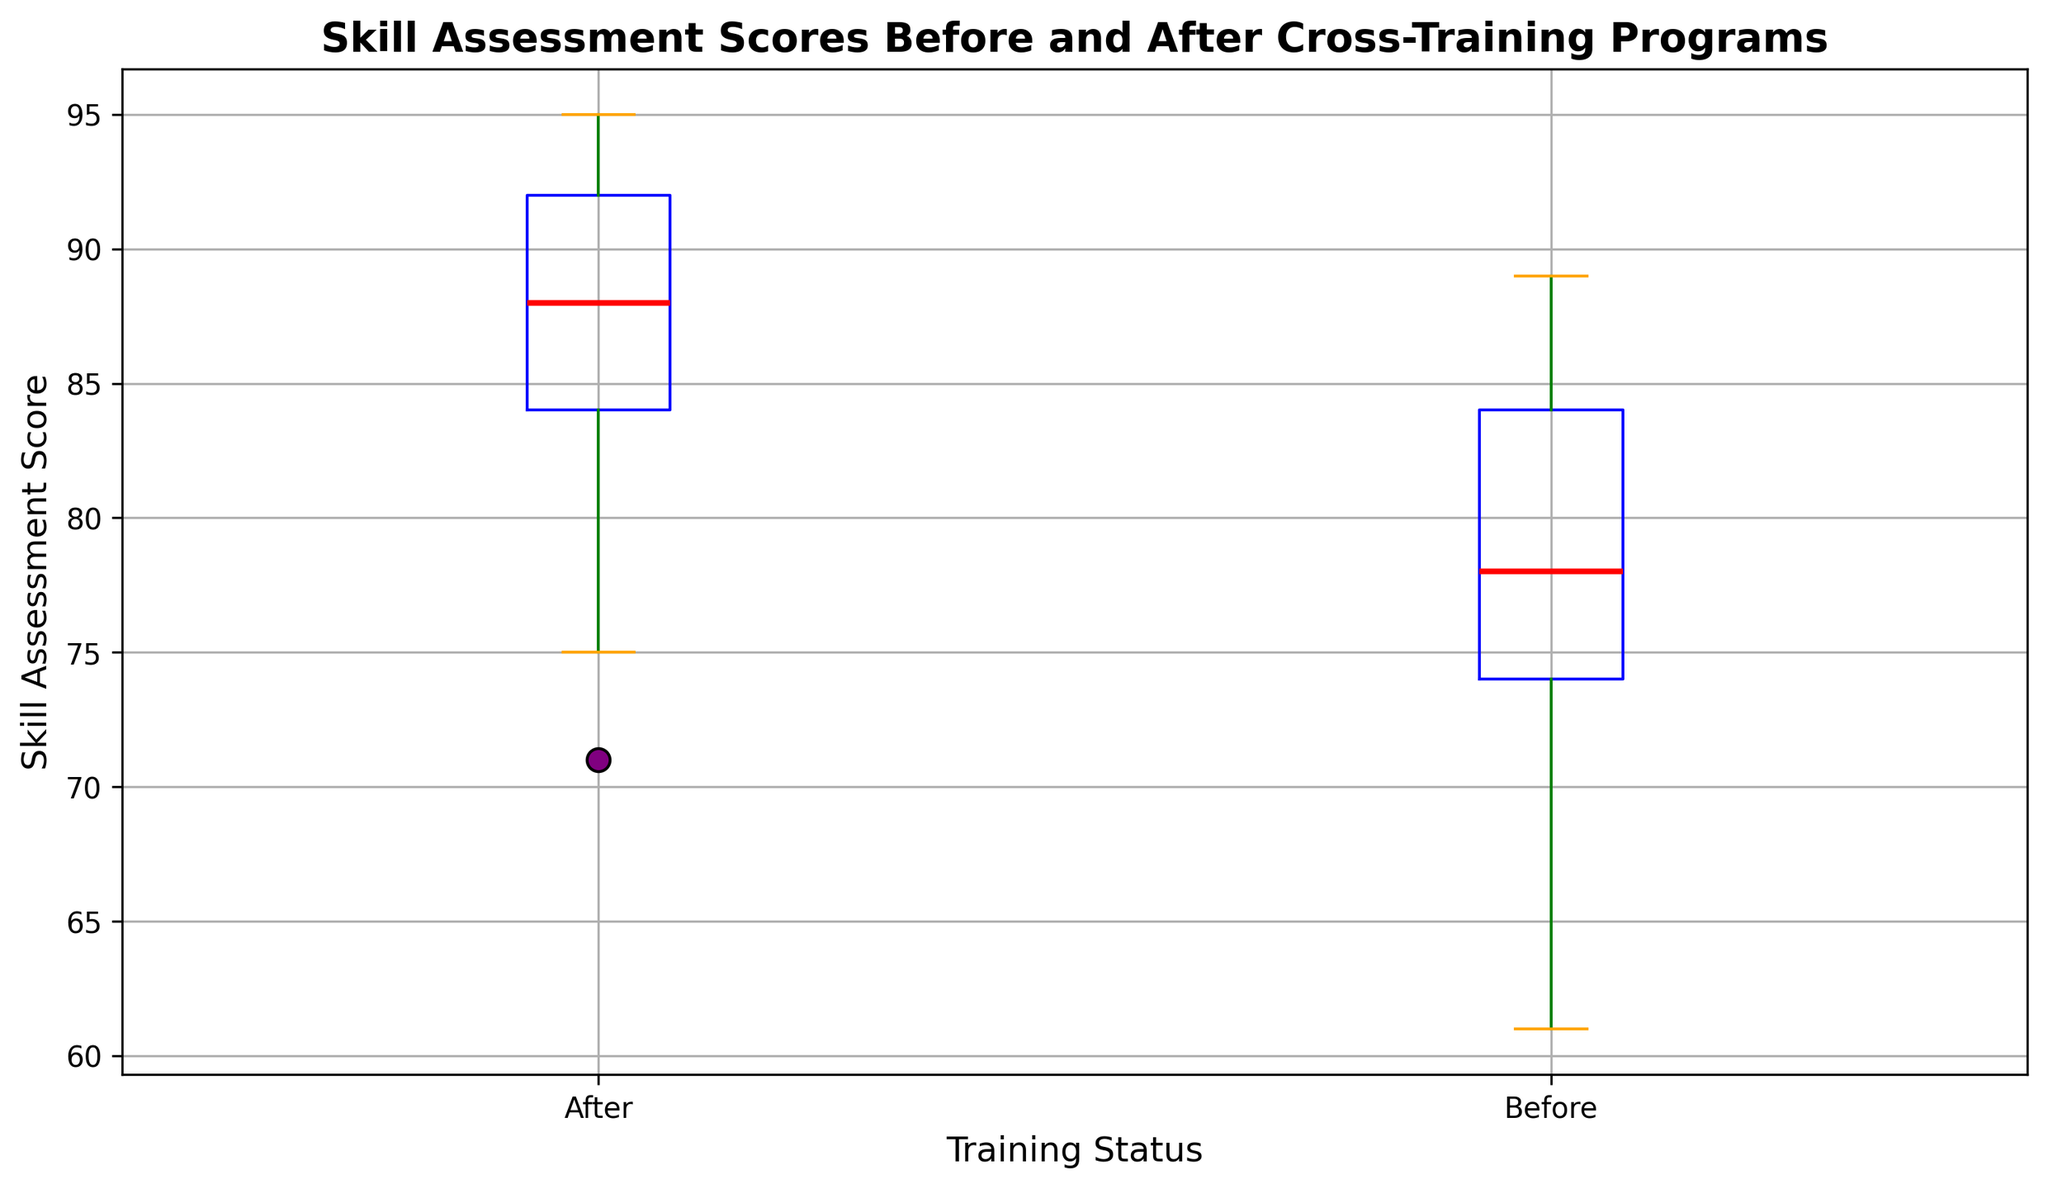What's the difference in the median skill assessment scores before and after cross-training programs? To find the difference, identify the median values for the two groups. The median value is the red line inside each box. Subtract the median "Before" score from the median "After" score.
Answer: 10 Which training status has a higher variability in skill assessment scores? Variability is represented by the length of the box and whiskers. The "Before" box appears taller and its whiskers are longer, indicating higher variability compared to the "After" box.
Answer: Before What is the interquartile range (IQR) of the skill assessment scores after cross-training programs? The IQR is the range covered by the box, which represents the middle 50% of the data. Find the values at the top (Q3) and bottom (Q1) of the box for the "After" group and subtract Q1 from Q3.
Answer: 10 How did the minimum skill assessment score change after cross-training programs? Look at the lowest ends of the whiskers for both "Before" and "After" groups. Compare the minimum values for the two groups. The "Before" minimum is around 61, and the "After" minimum is around 71.
Answer: Increased by 10 What is the maximum skill assessment score before cross-training programs? The maximum is represented by the top end of the whisker in the "Before" group. This is slightly below the 90 mark.
Answer: 89 Which training status has a broader range of skill assessment scores? The range is the distance between the lowest and highest whiskers. Compare the length of the whiskers for both groups. The "Before" group has a broader range.
Answer: Before What does the position of the red median line signify in the context of this box plot? The red line inside each box represents the median value of the skill assessment scores for the respective groups. It shows that the median score has increased after cross-training.
Answer: Median value Are there any outliers in the skill assessment scores before cross-training programs? Outliers are represented by dots outside the whiskers. In the "Before" group, there are no dots outside the whiskers, indicating no outliers.
Answer: No What is the median skill assessment score after cross-training programs? The red line inside the "After" box represents the median. The line is at the 90 mark.
Answer: 90 